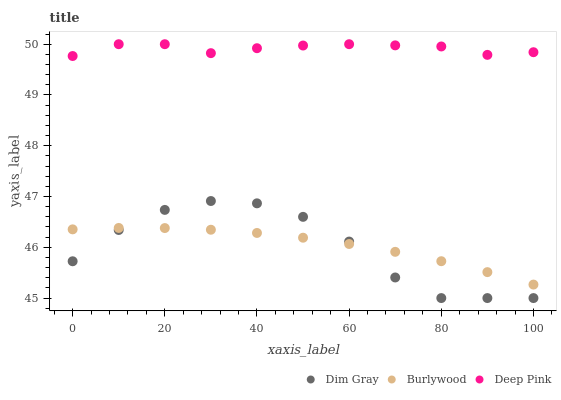Does Dim Gray have the minimum area under the curve?
Answer yes or no. Yes. Does Deep Pink have the maximum area under the curve?
Answer yes or no. Yes. Does Deep Pink have the minimum area under the curve?
Answer yes or no. No. Does Dim Gray have the maximum area under the curve?
Answer yes or no. No. Is Burlywood the smoothest?
Answer yes or no. Yes. Is Dim Gray the roughest?
Answer yes or no. Yes. Is Deep Pink the smoothest?
Answer yes or no. No. Is Deep Pink the roughest?
Answer yes or no. No. Does Dim Gray have the lowest value?
Answer yes or no. Yes. Does Deep Pink have the lowest value?
Answer yes or no. No. Does Deep Pink have the highest value?
Answer yes or no. Yes. Does Dim Gray have the highest value?
Answer yes or no. No. Is Dim Gray less than Deep Pink?
Answer yes or no. Yes. Is Deep Pink greater than Dim Gray?
Answer yes or no. Yes. Does Dim Gray intersect Burlywood?
Answer yes or no. Yes. Is Dim Gray less than Burlywood?
Answer yes or no. No. Is Dim Gray greater than Burlywood?
Answer yes or no. No. Does Dim Gray intersect Deep Pink?
Answer yes or no. No. 